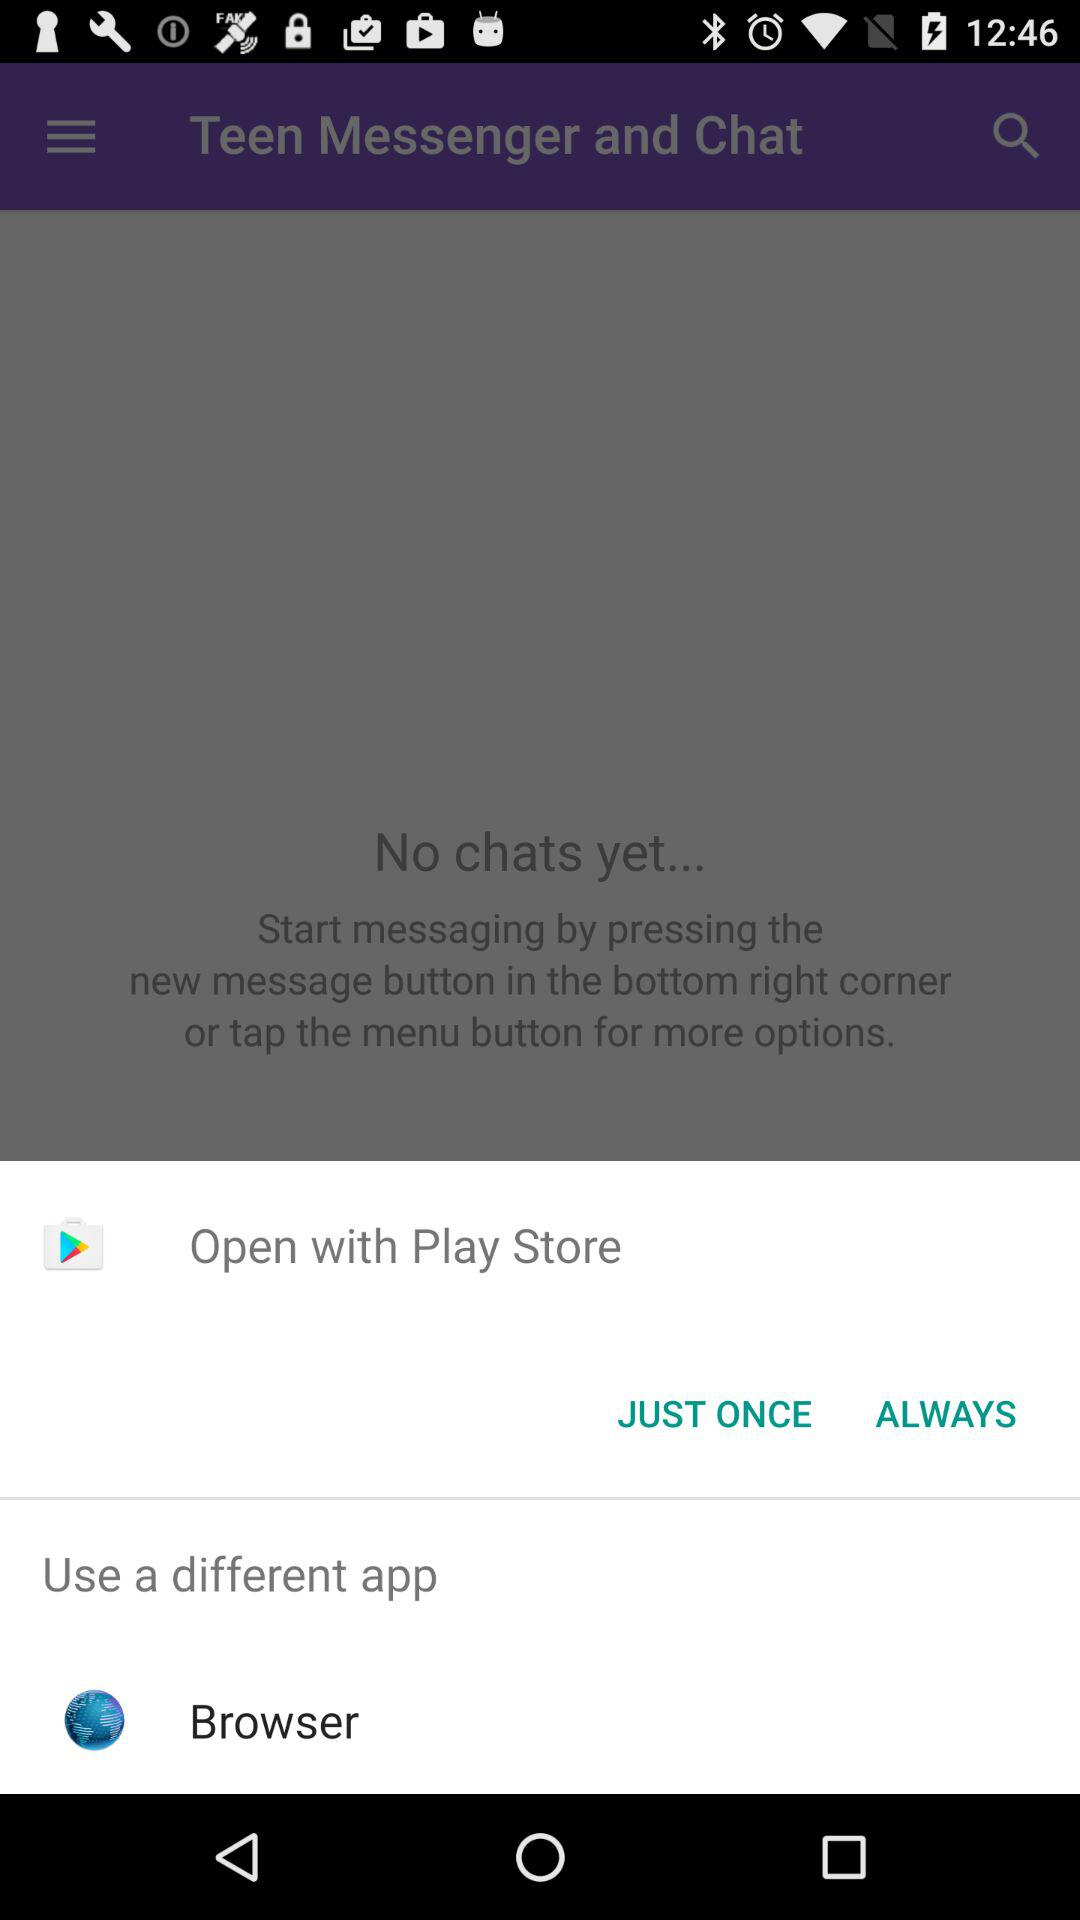What is the different option given to open it? The different option given to open it is Browser. 